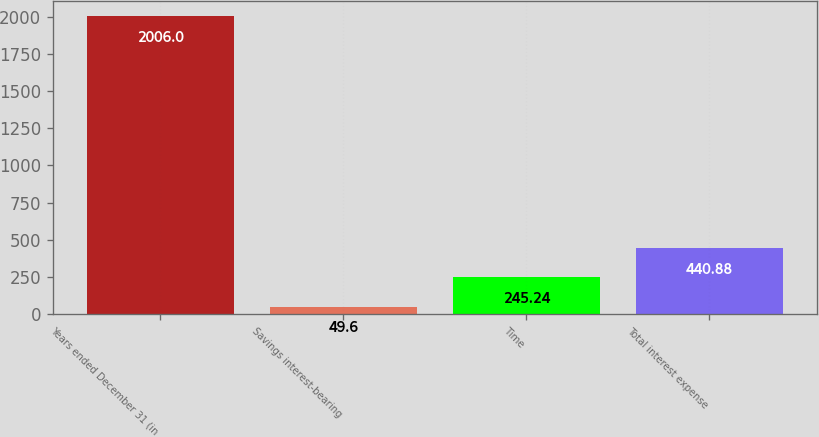Convert chart to OTSL. <chart><loc_0><loc_0><loc_500><loc_500><bar_chart><fcel>Years ended December 31 (in<fcel>Savings interest-bearing<fcel>Time<fcel>Total interest expense<nl><fcel>2006<fcel>49.6<fcel>245.24<fcel>440.88<nl></chart> 